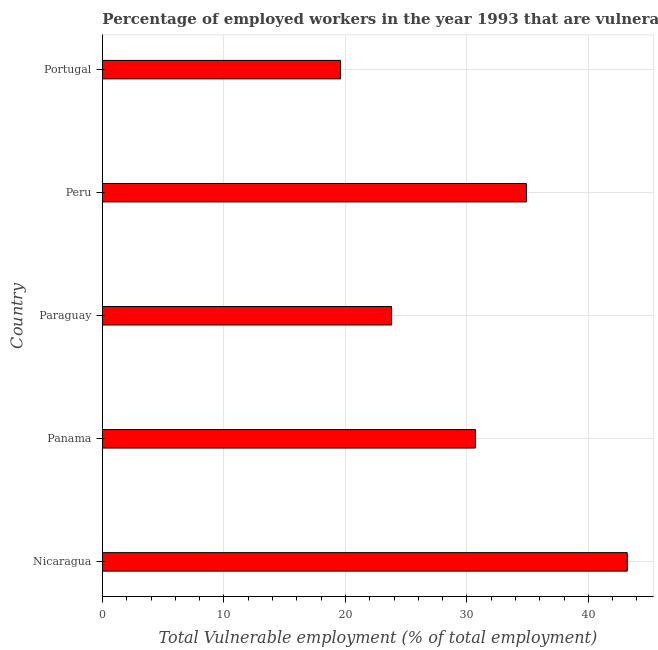What is the title of the graph?
Offer a terse response. Percentage of employed workers in the year 1993 that are vulnerable to fall into poverty. What is the label or title of the X-axis?
Give a very brief answer. Total Vulnerable employment (% of total employment). What is the total vulnerable employment in Portugal?
Offer a terse response. 19.6. Across all countries, what is the maximum total vulnerable employment?
Offer a very short reply. 43.2. Across all countries, what is the minimum total vulnerable employment?
Your answer should be very brief. 19.6. In which country was the total vulnerable employment maximum?
Provide a succinct answer. Nicaragua. What is the sum of the total vulnerable employment?
Give a very brief answer. 152.2. What is the average total vulnerable employment per country?
Your answer should be very brief. 30.44. What is the median total vulnerable employment?
Provide a succinct answer. 30.7. What is the ratio of the total vulnerable employment in Paraguay to that in Portugal?
Ensure brevity in your answer.  1.21. Is the sum of the total vulnerable employment in Panama and Paraguay greater than the maximum total vulnerable employment across all countries?
Your response must be concise. Yes. What is the difference between the highest and the lowest total vulnerable employment?
Make the answer very short. 23.6. How many bars are there?
Keep it short and to the point. 5. Are all the bars in the graph horizontal?
Your response must be concise. Yes. What is the Total Vulnerable employment (% of total employment) of Nicaragua?
Offer a terse response. 43.2. What is the Total Vulnerable employment (% of total employment) in Panama?
Ensure brevity in your answer.  30.7. What is the Total Vulnerable employment (% of total employment) in Paraguay?
Provide a short and direct response. 23.8. What is the Total Vulnerable employment (% of total employment) in Peru?
Provide a succinct answer. 34.9. What is the Total Vulnerable employment (% of total employment) in Portugal?
Give a very brief answer. 19.6. What is the difference between the Total Vulnerable employment (% of total employment) in Nicaragua and Panama?
Ensure brevity in your answer.  12.5. What is the difference between the Total Vulnerable employment (% of total employment) in Nicaragua and Paraguay?
Your answer should be compact. 19.4. What is the difference between the Total Vulnerable employment (% of total employment) in Nicaragua and Portugal?
Keep it short and to the point. 23.6. What is the difference between the Total Vulnerable employment (% of total employment) in Panama and Peru?
Provide a short and direct response. -4.2. What is the difference between the Total Vulnerable employment (% of total employment) in Panama and Portugal?
Provide a succinct answer. 11.1. What is the difference between the Total Vulnerable employment (% of total employment) in Paraguay and Peru?
Your answer should be compact. -11.1. What is the difference between the Total Vulnerable employment (% of total employment) in Paraguay and Portugal?
Provide a short and direct response. 4.2. What is the difference between the Total Vulnerable employment (% of total employment) in Peru and Portugal?
Provide a short and direct response. 15.3. What is the ratio of the Total Vulnerable employment (% of total employment) in Nicaragua to that in Panama?
Give a very brief answer. 1.41. What is the ratio of the Total Vulnerable employment (% of total employment) in Nicaragua to that in Paraguay?
Offer a very short reply. 1.81. What is the ratio of the Total Vulnerable employment (% of total employment) in Nicaragua to that in Peru?
Make the answer very short. 1.24. What is the ratio of the Total Vulnerable employment (% of total employment) in Nicaragua to that in Portugal?
Provide a short and direct response. 2.2. What is the ratio of the Total Vulnerable employment (% of total employment) in Panama to that in Paraguay?
Provide a short and direct response. 1.29. What is the ratio of the Total Vulnerable employment (% of total employment) in Panama to that in Portugal?
Your response must be concise. 1.57. What is the ratio of the Total Vulnerable employment (% of total employment) in Paraguay to that in Peru?
Provide a succinct answer. 0.68. What is the ratio of the Total Vulnerable employment (% of total employment) in Paraguay to that in Portugal?
Your answer should be very brief. 1.21. What is the ratio of the Total Vulnerable employment (% of total employment) in Peru to that in Portugal?
Give a very brief answer. 1.78. 